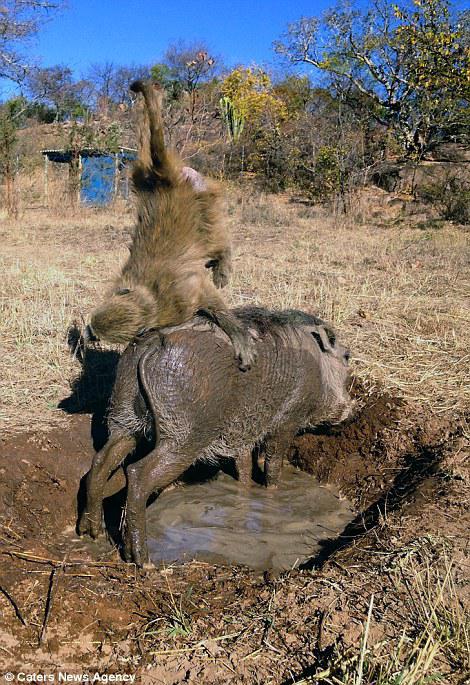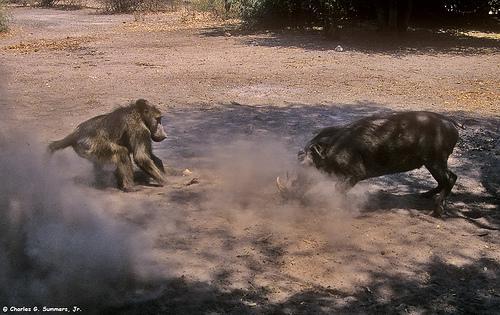The first image is the image on the left, the second image is the image on the right. Examine the images to the left and right. Is the description "The right image has a monkey interacting with a warthog." accurate? Answer yes or no. Yes. The first image is the image on the left, the second image is the image on the right. Evaluate the accuracy of this statement regarding the images: "At least one photo contains a monkey on top of a warthog.". Is it true? Answer yes or no. Yes. 